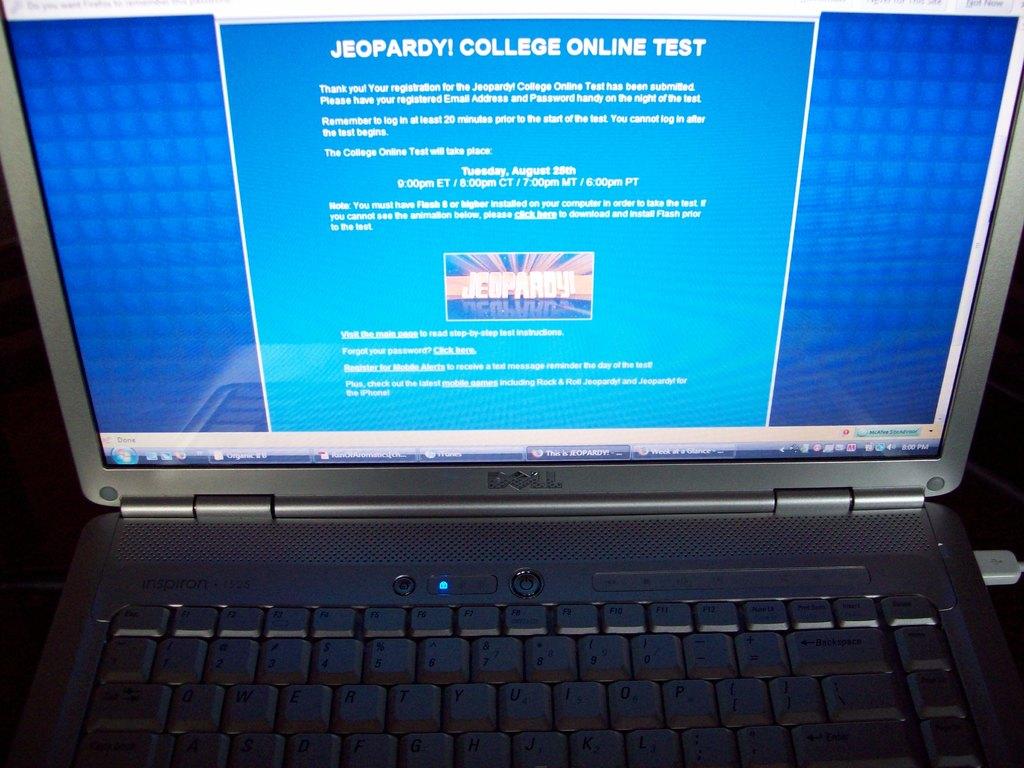What show is referenced in this page?
Offer a very short reply. Jeopardy. What kind of test is on the screen?
Provide a short and direct response. Jeopardy! college online test. 